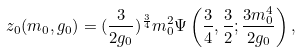<formula> <loc_0><loc_0><loc_500><loc_500>z _ { 0 } ( m _ { 0 } , g _ { 0 } ) = ( \frac { 3 } { 2 g _ { 0 } } ) ^ { \frac { 3 } { 4 } } m _ { 0 } ^ { 2 } \Psi \left ( \frac { 3 } { 4 } , \frac { 3 } { 2 } ; \frac { 3 m _ { 0 } ^ { 4 } } { 2 g _ { 0 } } \right ) ,</formula> 